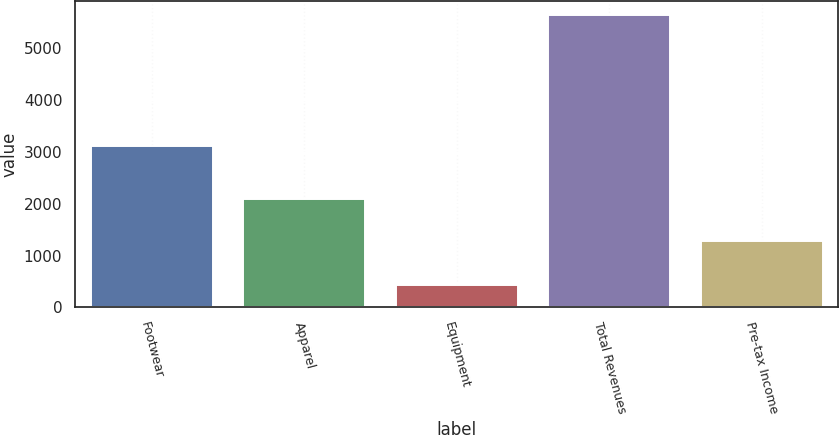Convert chart. <chart><loc_0><loc_0><loc_500><loc_500><bar_chart><fcel>Footwear<fcel>Apparel<fcel>Equipment<fcel>Total Revenues<fcel>Pre-tax Income<nl><fcel>3112.6<fcel>2083.5<fcel>433.1<fcel>5629.2<fcel>1281.9<nl></chart> 